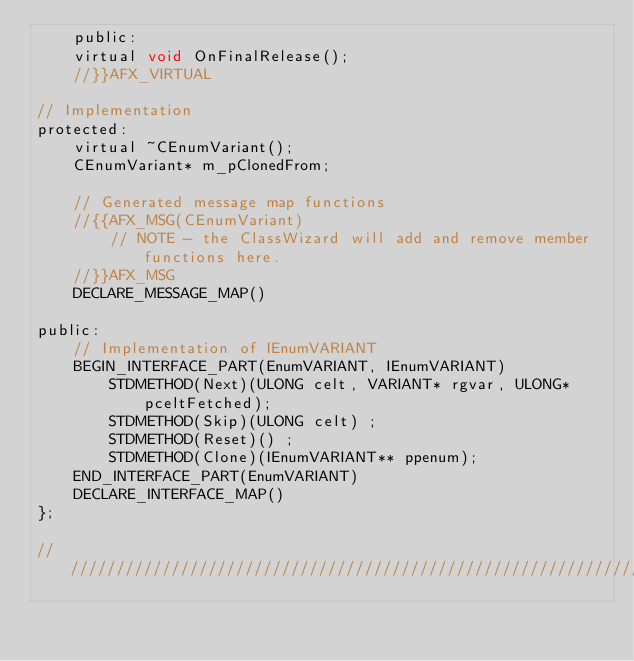Convert code to text. <code><loc_0><loc_0><loc_500><loc_500><_C_>	public:
	virtual void OnFinalRelease();
	//}}AFX_VIRTUAL

// Implementation
protected:
	virtual ~CEnumVariant();
	CEnumVariant* m_pClonedFrom;

	// Generated message map functions
	//{{AFX_MSG(CEnumVariant)
		// NOTE - the ClassWizard will add and remove member functions here.
	//}}AFX_MSG
	DECLARE_MESSAGE_MAP()

public:
	// Implementation of IEnumVARIANT
	BEGIN_INTERFACE_PART(EnumVARIANT, IEnumVARIANT)
		STDMETHOD(Next)(ULONG celt, VARIANT* rgvar, ULONG* pceltFetched);
		STDMETHOD(Skip)(ULONG celt) ;
		STDMETHOD(Reset)() ;
		STDMETHOD(Clone)(IEnumVARIANT** ppenum);
	END_INTERFACE_PART(EnumVARIANT)
	DECLARE_INTERFACE_MAP()
};

/////////////////////////////////////////////////////////////////////////////
</code> 